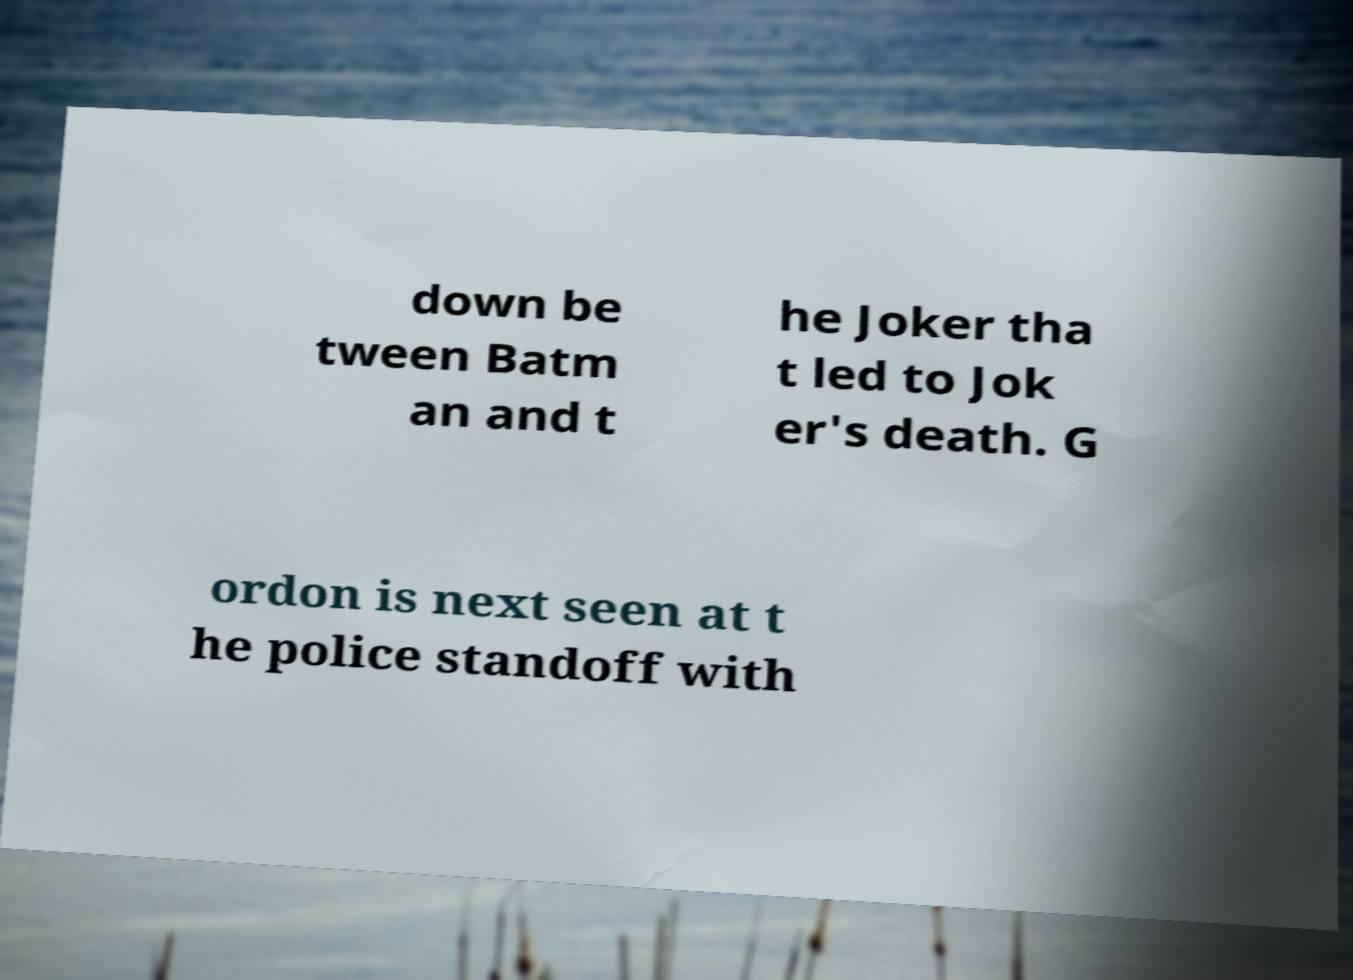What messages or text are displayed in this image? I need them in a readable, typed format. down be tween Batm an and t he Joker tha t led to Jok er's death. G ordon is next seen at t he police standoff with 